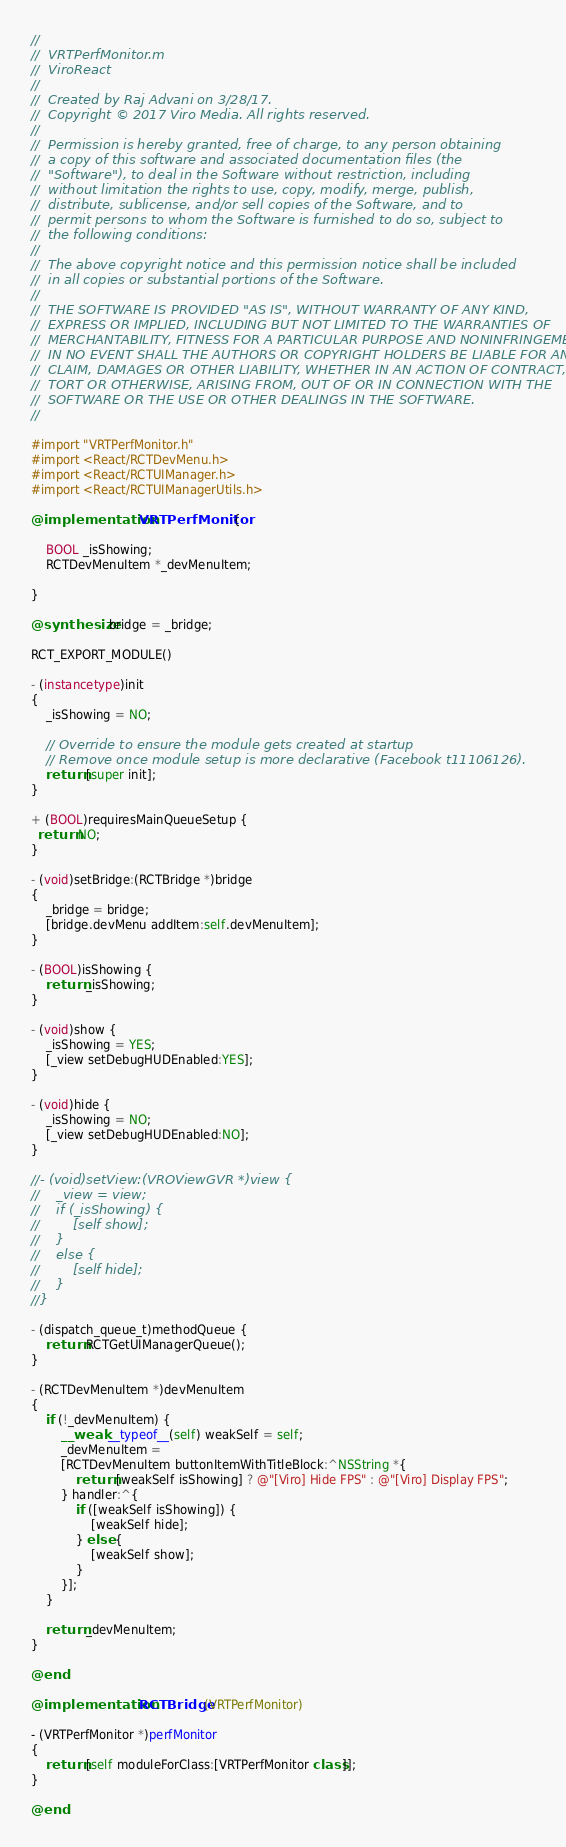<code> <loc_0><loc_0><loc_500><loc_500><_ObjectiveC_>//
//  VRTPerfMonitor.m
//  ViroReact
//
//  Created by Raj Advani on 3/28/17.
//  Copyright © 2017 Viro Media. All rights reserved.
//
//  Permission is hereby granted, free of charge, to any person obtaining
//  a copy of this software and associated documentation files (the
//  "Software"), to deal in the Software without restriction, including
//  without limitation the rights to use, copy, modify, merge, publish,
//  distribute, sublicense, and/or sell copies of the Software, and to
//  permit persons to whom the Software is furnished to do so, subject to
//  the following conditions:
//
//  The above copyright notice and this permission notice shall be included
//  in all copies or substantial portions of the Software.
//
//  THE SOFTWARE IS PROVIDED "AS IS", WITHOUT WARRANTY OF ANY KIND,
//  EXPRESS OR IMPLIED, INCLUDING BUT NOT LIMITED TO THE WARRANTIES OF
//  MERCHANTABILITY, FITNESS FOR A PARTICULAR PURPOSE AND NONINFRINGEMENT.
//  IN NO EVENT SHALL THE AUTHORS OR COPYRIGHT HOLDERS BE LIABLE FOR ANY
//  CLAIM, DAMAGES OR OTHER LIABILITY, WHETHER IN AN ACTION OF CONTRACT,
//  TORT OR OTHERWISE, ARISING FROM, OUT OF OR IN CONNECTION WITH THE
//  SOFTWARE OR THE USE OR OTHER DEALINGS IN THE SOFTWARE.
//

#import "VRTPerfMonitor.h"
#import <React/RCTDevMenu.h>
#import <React/RCTUIManager.h>
#import <React/RCTUIManagerUtils.h>

@implementation VRTPerfMonitor {
    
    BOOL _isShowing;
    RCTDevMenuItem *_devMenuItem;
    
}

@synthesize bridge = _bridge;

RCT_EXPORT_MODULE()

- (instancetype)init
{
    _isShowing = NO;
    
    // Override to ensure the module gets created at startup
    // Remove once module setup is more declarative (Facebook t11106126).
    return [super init];
}

+ (BOOL)requiresMainQueueSetup {
  return NO;
}

- (void)setBridge:(RCTBridge *)bridge
{
    _bridge = bridge;
    [bridge.devMenu addItem:self.devMenuItem];
}

- (BOOL)isShowing {
    return _isShowing;
}

- (void)show {
    _isShowing = YES;
    [_view setDebugHUDEnabled:YES];
}

- (void)hide {
    _isShowing = NO;
    [_view setDebugHUDEnabled:NO];
}

//- (void)setView:(VROViewGVR *)view {
//    _view = view;
//    if (_isShowing) {
//        [self show];
//    }
//    else {
//        [self hide];
//    }
//}

- (dispatch_queue_t)methodQueue {
    return RCTGetUIManagerQueue();
}

- (RCTDevMenuItem *)devMenuItem
{
    if (!_devMenuItem) {
        __weak __typeof__(self) weakSelf = self;
        _devMenuItem =
        [RCTDevMenuItem buttonItemWithTitleBlock:^NSString *{
            return [weakSelf isShowing] ? @"[Viro] Hide FPS" : @"[Viro] Display FPS";
        } handler:^{
            if ([weakSelf isShowing]) {
                [weakSelf hide];
            } else {
                [weakSelf show];
            }
        }];
    }
    
    return _devMenuItem;
}

@end

@implementation RCTBridge (VRTPerfMonitor)

- (VRTPerfMonitor *)perfMonitor
{
    return [self moduleForClass:[VRTPerfMonitor class]];
}

@end
</code> 